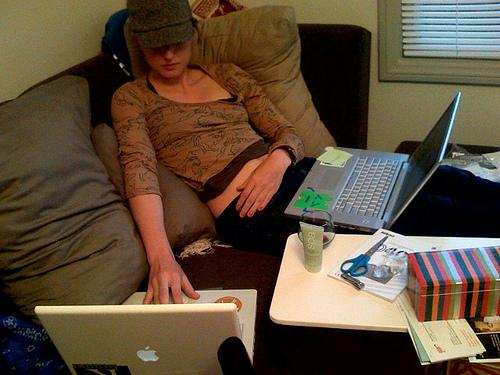Which item might she use on her skin?

Choices:
A) box
B) paper
C) metal
D) tube tube 